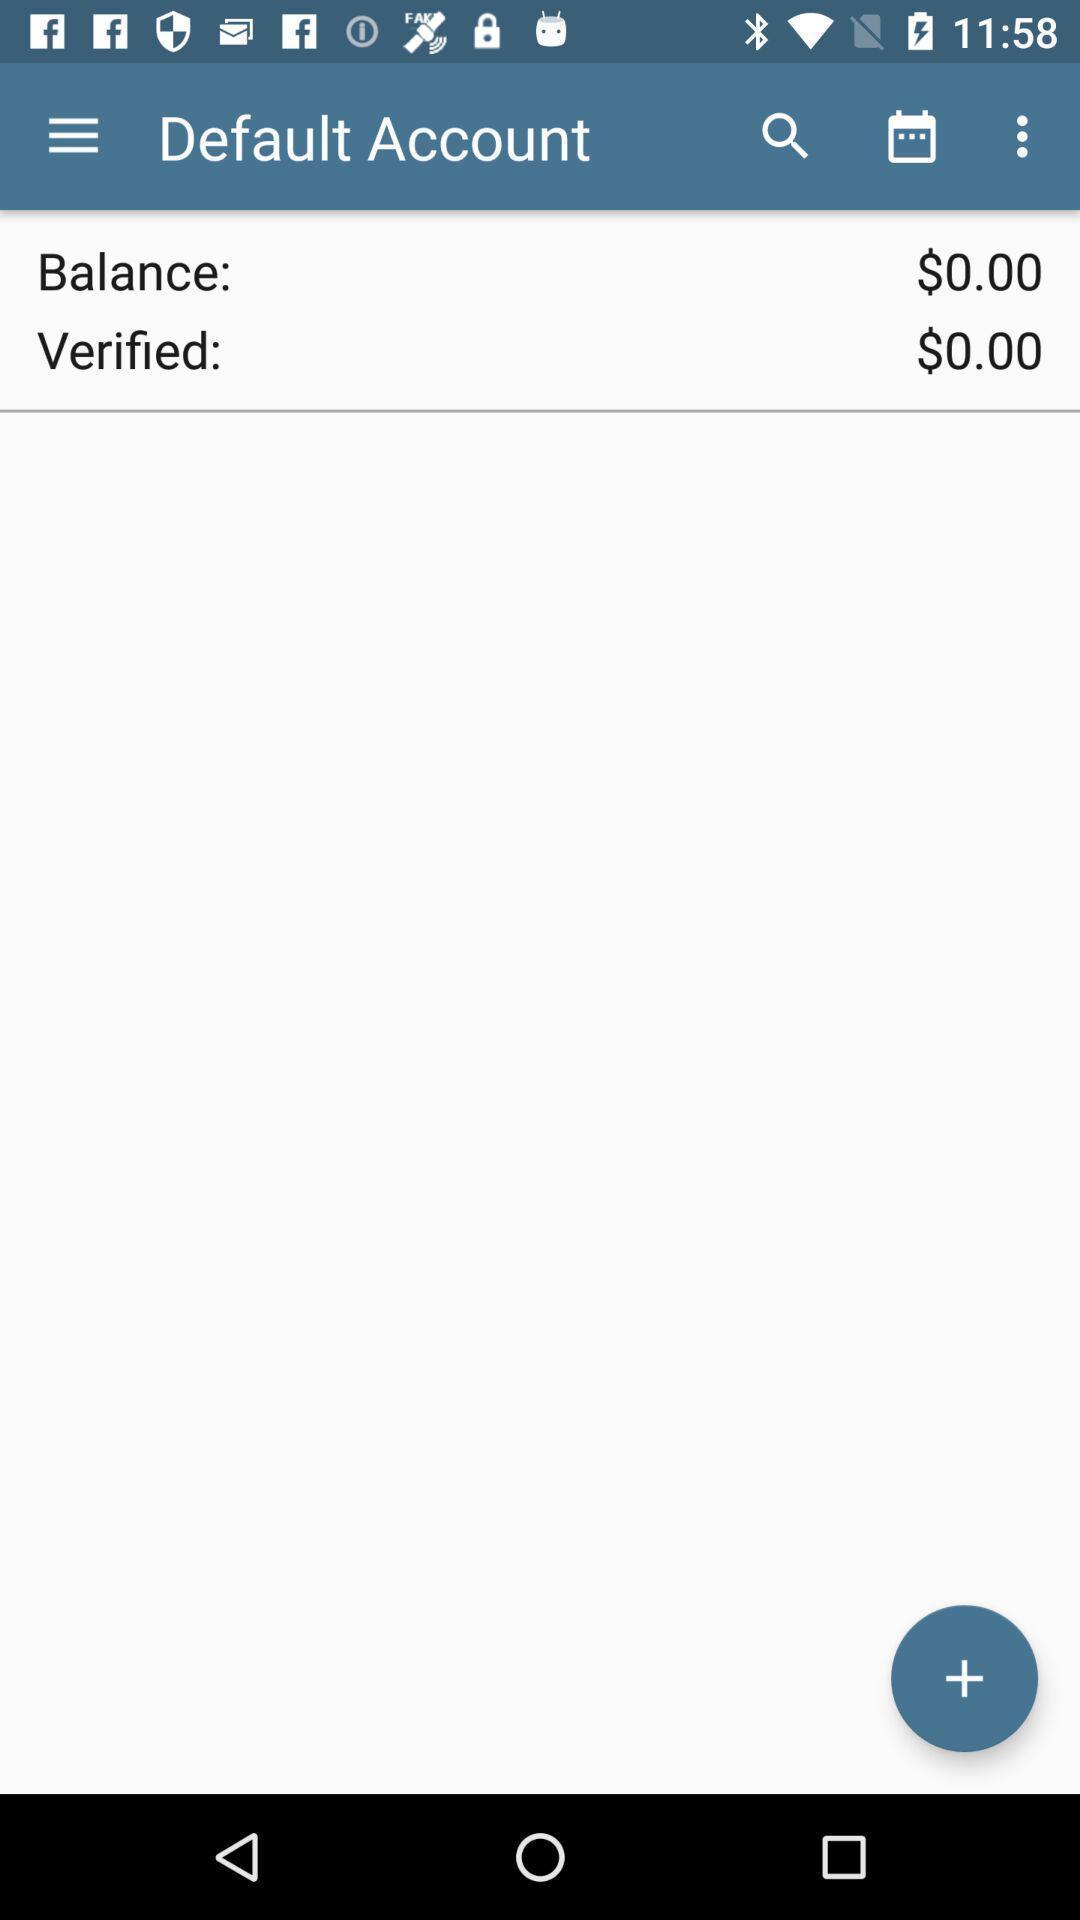Give me a summary of this screen capture. Screen displaying the default account page. 